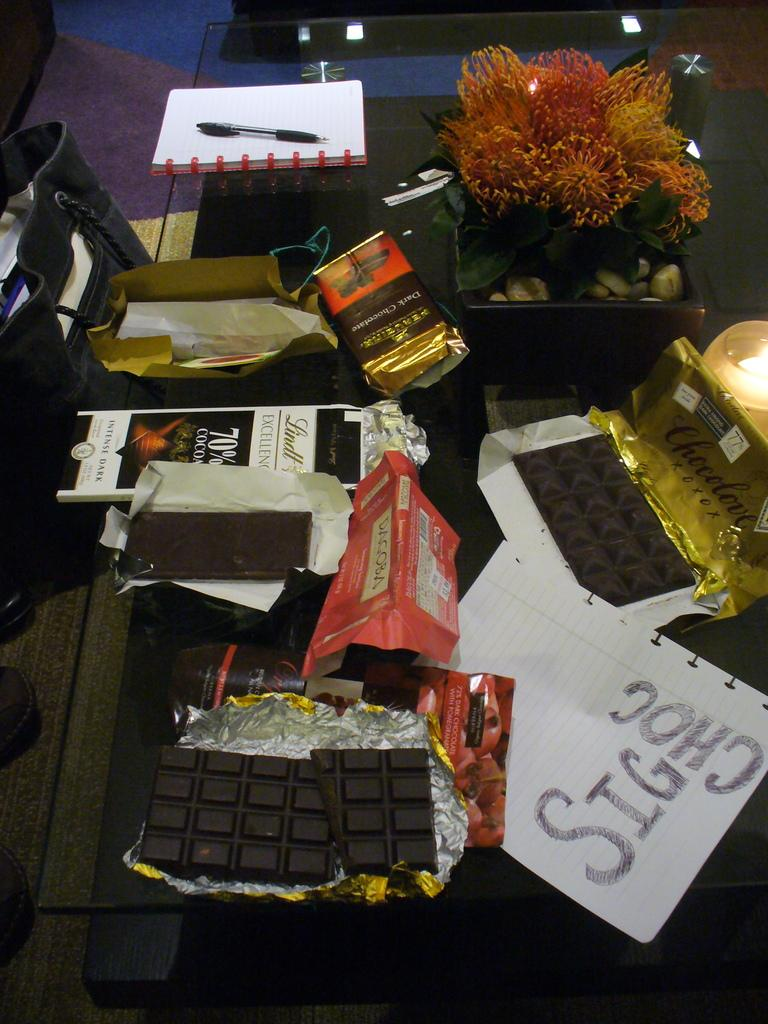What type of food is present in the image? There are chocolates in the image. What else can be seen in the image besides chocolates? There are papers and a flower pot in the image. Can you describe the location of the flower pot? The flower pot is on the surface of a glass in the image. What is visible on the left side of the image? There is a bag on the left side of the image. What type of soap is being used to clean the chocolates in the image? There is no soap present in the image, and the chocolates are not being cleaned. Can you tell me how many copies of the papers are in the image? There is no mention of multiple copies of the papers in the image; only one paper is mentioned. 